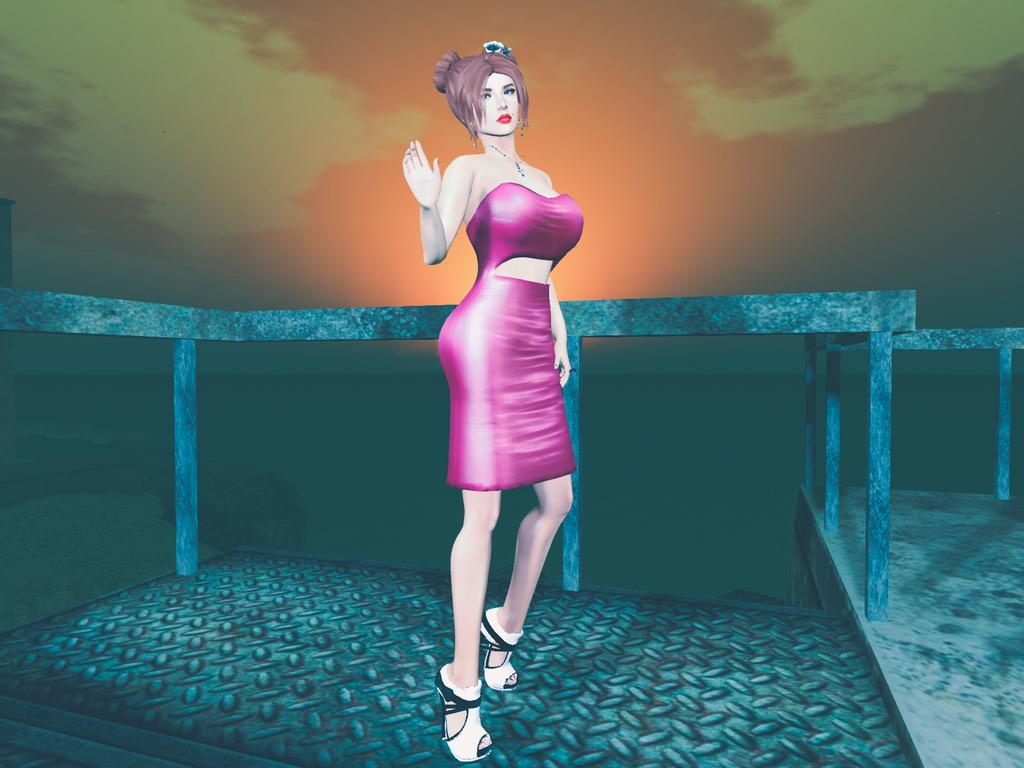What type of image is being described? The image is animated. What is the lady in the image doing? The lady is standing on a bridge. What can be seen in the background of the image? There is a river and the sky visible in the background. How much money does the robin have in its nest in the image? There is no robin or nest present in the image. What decision does the lady make while standing on the bridge in the image? The image does not provide any information about the lady's decision-making process. 